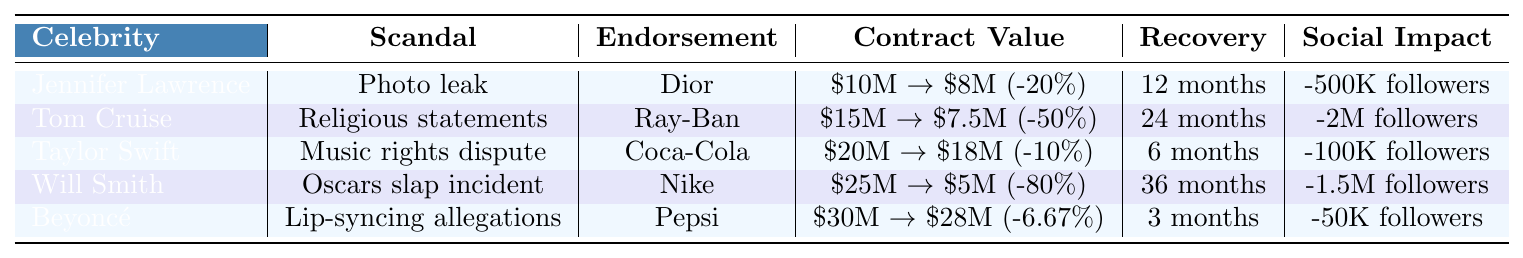What was the contract value for Will Smith before the scandal? The table indicates that Will Smith's contract value before the scandal was $25 million.
Answer: $25 million What is the percentage decrease in contract value for Tom Cruise? The contract value for Tom Cruise decreased from $15 million to $7.5 million, which is a 50% decrease.
Answer: 50% Which celebrity had the highest social media followers lost after their scandal? Will Smith lost 1.5 million followers, which is the highest among all listed celebrities.
Answer: Will Smith How long did it take for Beyoncé to recover after the scandal? The table shows that Beyoncé's recovery time was 3 months after the scandal.
Answer: 3 months Was a public apology issued by Taylor Swift after her scandal? According to the table, Taylor Swift did issue a public apology following her scandal.
Answer: Yes What is the average contract value for endorsements before the scandals? Summing the contract values before the scandal ($10M + $15M + $20M + $25M + $30M = $100M) and dividing by 5 gives an average of $20 million.
Answer: $20 million Which celebrity had the least recovery time? By comparing the recovery times, Beyoncé had the least recovery time of 3 months.
Answer: Beyoncé How much did Jennifer Lawrence donate to charity post-scandal? The table indicates that Jennifer Lawrence donated $1 million to charity after her scandal.
Answer: $1 million Calculate the total percentage decrease in contract value for all celebrities. The total percentage decreases are: 20% + 50% + 10% + 80% + 6.67% = 166.67%, and dividing by 5 gives an average percentage decrease of 33.33%.
Answer: 33.33% Was there a scandal related to music rights for any celebrity? Yes, Taylor Swift had a scandal related to music rights dispute.
Answer: Yes 